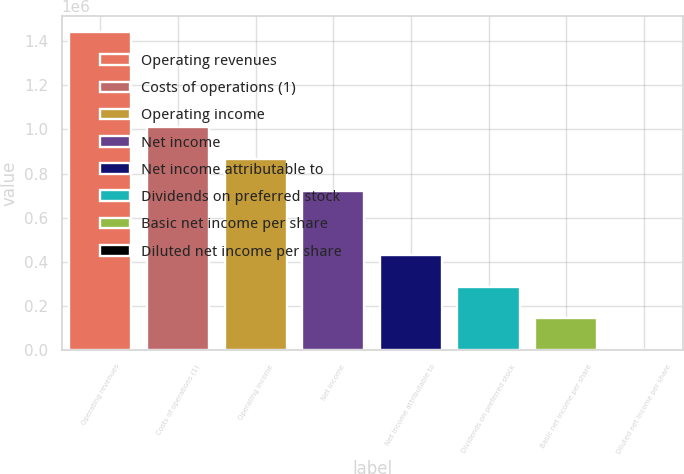Convert chart to OTSL. <chart><loc_0><loc_0><loc_500><loc_500><bar_chart><fcel>Operating revenues<fcel>Costs of operations (1)<fcel>Operating income<fcel>Net income<fcel>Net income attributable to<fcel>Dividends on preferred stock<fcel>Basic net income per share<fcel>Diluted net income per share<nl><fcel>1.44223e+06<fcel>1.00956e+06<fcel>865336<fcel>721114<fcel>432668<fcel>288446<fcel>144223<fcel>0.37<nl></chart> 